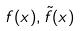<formula> <loc_0><loc_0><loc_500><loc_500>f ( x ) , \tilde { f } ( x )</formula> 